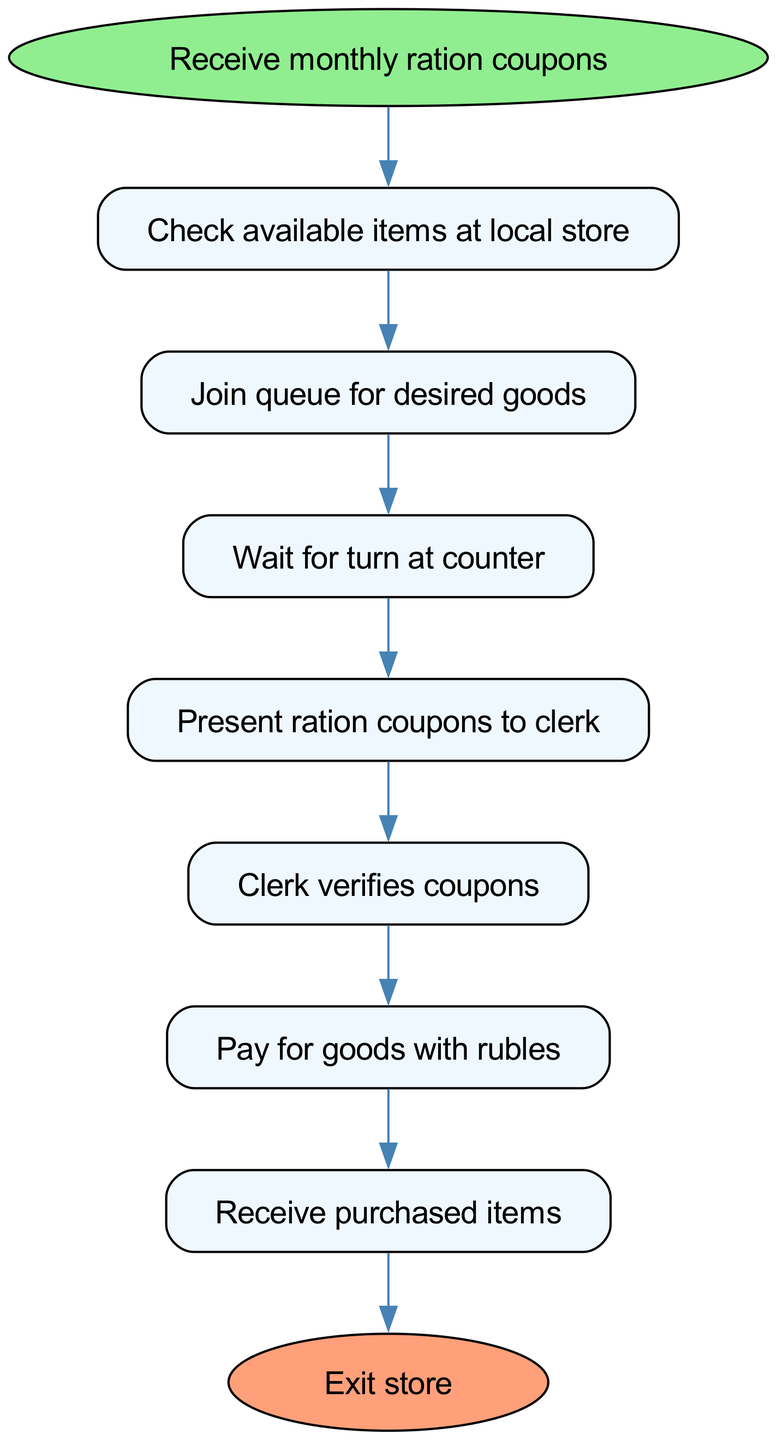What is the starting point of the procedure? The starting point of the procedure, as indicated in the diagram, is labeled "Receive monthly ration coupons." This is the first step that initiates the entire process of purchasing goods with ration coupons.
Answer: Receive monthly ration coupons What is the last step before exiting the store? The last step before exiting the store is "Receive purchased items." According to the flow of the diagram, this comes just before moving to the final step of exiting the store.
Answer: Receive purchased items How many steps are there in total? To determine the total number of steps, we look at each stage in the flow chart after the starting point. There are 7 steps leading from start to end, including the steps that represent actions taken in the process.
Answer: 7 What action follows checking available items at the local store? After checking available items at the local store, the next action is "Join queue for desired goods." This indicates what you proceed to do after assessing what items are available.
Answer: Join queue for desired goods What is required to be presented to the clerk? The item required to be presented to the clerk is "ration coupons." This is a crucial step in the flow as it is necessary for the verification before payment is made.
Answer: Ration coupons What happens after the clerk verifies the coupons? Once the clerk verifies the coupons, the next action is "Pay for goods with rubles." This step indicates the financial transaction that follows the confirmation of valid coupons.
Answer: Pay for goods with rubles Which step involves waiting? The step that involves waiting is "Wait for turn at counter." This indicates that there is a period during which one must wait before their turn to complete the purchase at the store.
Answer: Wait for turn at counter What is the first action to take when you receive the coupons? The first action to take upon receiving the coupons is to "Check available items at local store." This step is crucial as it determines whether you can proceed to purchase something or not.
Answer: Check available items at local store What does joining a queue lead to? Joining a queue leads to "Wait for turn at counter." This relationship indicates the flow from queuing to the next necessary action while purchasing items.
Answer: Wait for turn at counter 